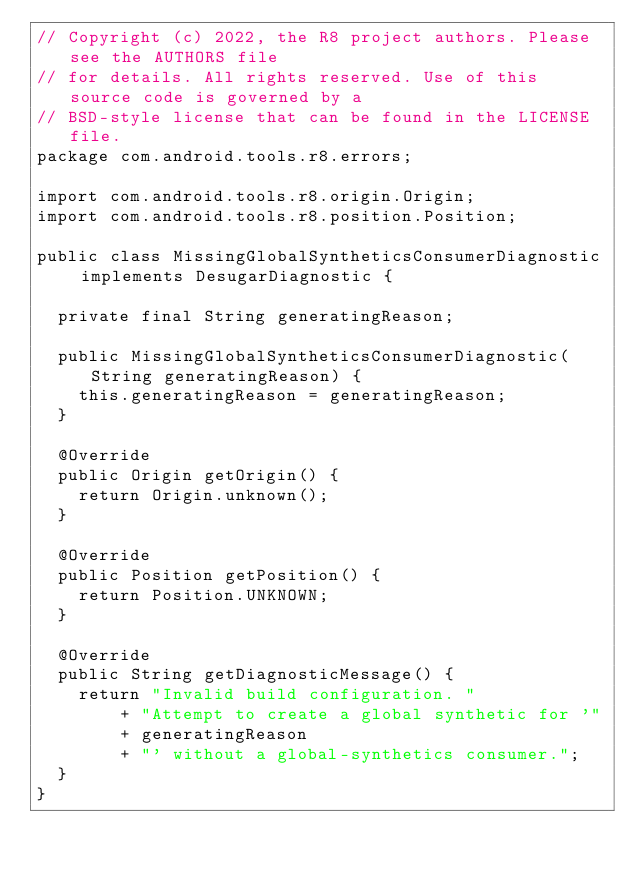Convert code to text. <code><loc_0><loc_0><loc_500><loc_500><_Java_>// Copyright (c) 2022, the R8 project authors. Please see the AUTHORS file
// for details. All rights reserved. Use of this source code is governed by a
// BSD-style license that can be found in the LICENSE file.
package com.android.tools.r8.errors;

import com.android.tools.r8.origin.Origin;
import com.android.tools.r8.position.Position;

public class MissingGlobalSyntheticsConsumerDiagnostic implements DesugarDiagnostic {

  private final String generatingReason;

  public MissingGlobalSyntheticsConsumerDiagnostic(String generatingReason) {
    this.generatingReason = generatingReason;
  }

  @Override
  public Origin getOrigin() {
    return Origin.unknown();
  }

  @Override
  public Position getPosition() {
    return Position.UNKNOWN;
  }

  @Override
  public String getDiagnosticMessage() {
    return "Invalid build configuration. "
        + "Attempt to create a global synthetic for '"
        + generatingReason
        + "' without a global-synthetics consumer.";
  }
}
</code> 